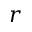Convert formula to latex. <formula><loc_0><loc_0><loc_500><loc_500>r</formula> 